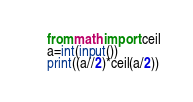<code> <loc_0><loc_0><loc_500><loc_500><_Python_>from math import ceil
a=int(input())
print((a//2)*ceil(a/2))</code> 